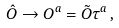<formula> <loc_0><loc_0><loc_500><loc_500>\hat { O } \to O ^ { a } = \tilde { O } \tau ^ { a } \, ,</formula> 